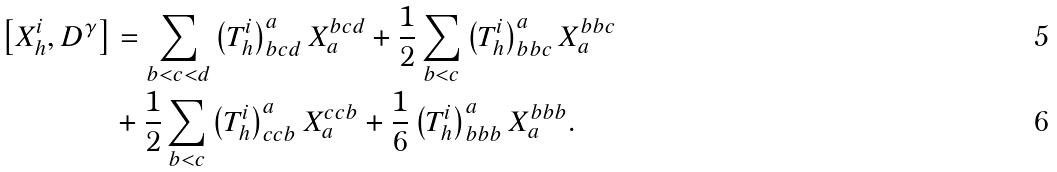Convert formula to latex. <formula><loc_0><loc_0><loc_500><loc_500>\left [ X _ { h } ^ { i } , D ^ { \gamma } \right ] & = \sum _ { b < c < d } \left ( T _ { h } ^ { i } \right ) _ { b c d } ^ { a } X _ { a } ^ { b c d } + \frac { 1 } { 2 } \sum _ { b < c } \left ( T _ { h } ^ { i } \right ) _ { b b c } ^ { a } X _ { a } ^ { b b c } \\ & + \frac { 1 } { 2 } \sum _ { b < c } \left ( T _ { h } ^ { i } \right ) _ { c c b } ^ { a } X _ { a } ^ { c c b } + \frac { 1 } { 6 } \left ( T _ { h } ^ { i } \right ) _ { b b b } ^ { a } X _ { a } ^ { b b b } .</formula> 